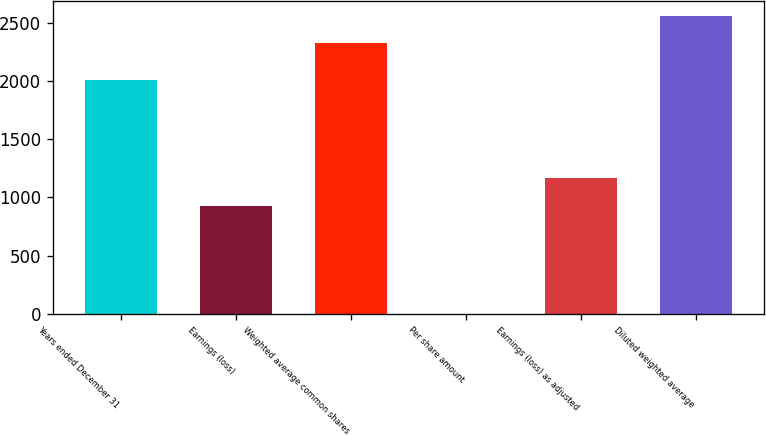Convert chart to OTSL. <chart><loc_0><loc_0><loc_500><loc_500><bar_chart><fcel>Years ended December 31<fcel>Earnings (loss)<fcel>Weighted average common shares<fcel>Per share amount<fcel>Earnings (loss) as adjusted<fcel>Diluted weighted average<nl><fcel>2003<fcel>928<fcel>2321.9<fcel>0.4<fcel>1163.08<fcel>2556.98<nl></chart> 